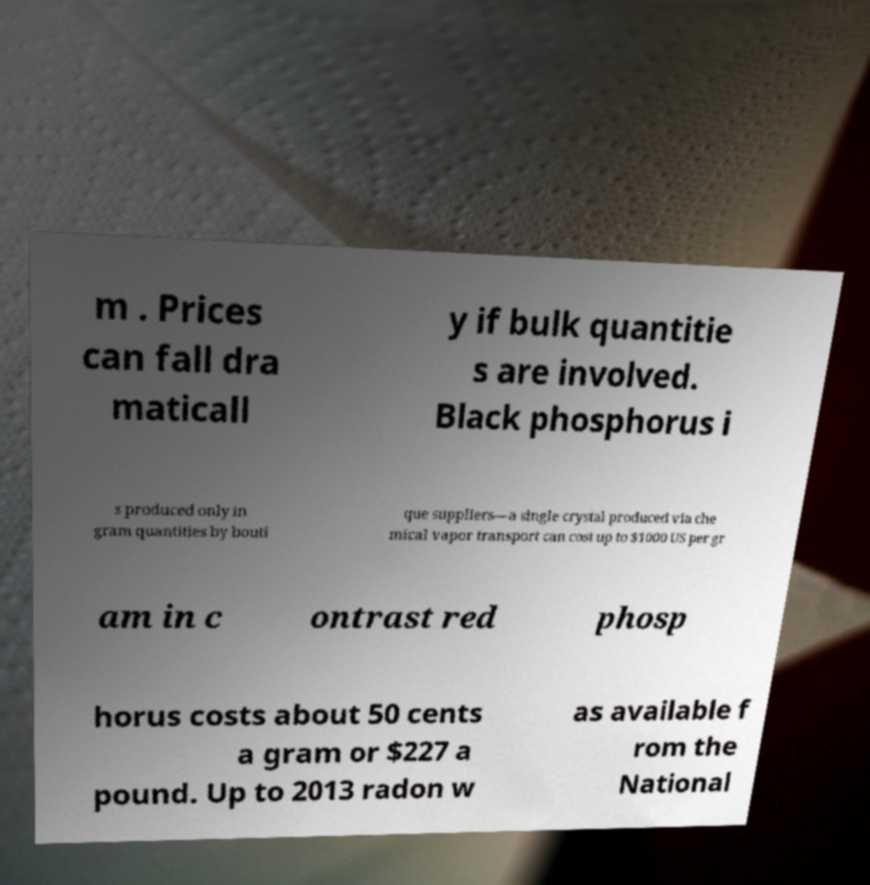For documentation purposes, I need the text within this image transcribed. Could you provide that? m . Prices can fall dra maticall y if bulk quantitie s are involved. Black phosphorus i s produced only in gram quantities by bouti que suppliers—a single crystal produced via che mical vapor transport can cost up to $1000 US per gr am in c ontrast red phosp horus costs about 50 cents a gram or $227 a pound. Up to 2013 radon w as available f rom the National 